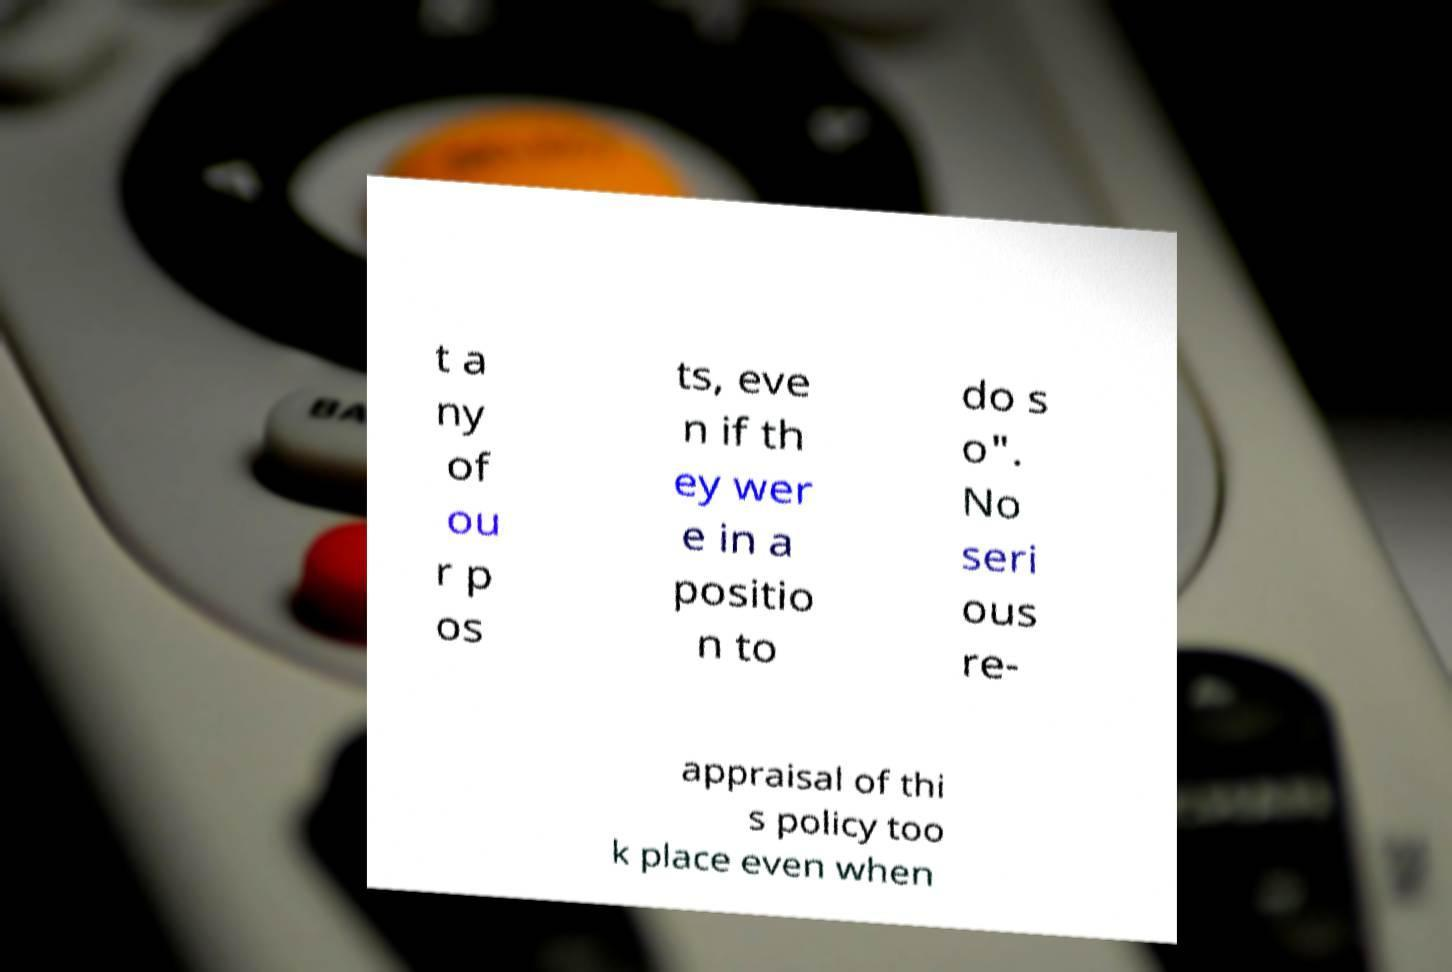Please read and relay the text visible in this image. What does it say? t a ny of ou r p os ts, eve n if th ey wer e in a positio n to do s o". No seri ous re- appraisal of thi s policy too k place even when 